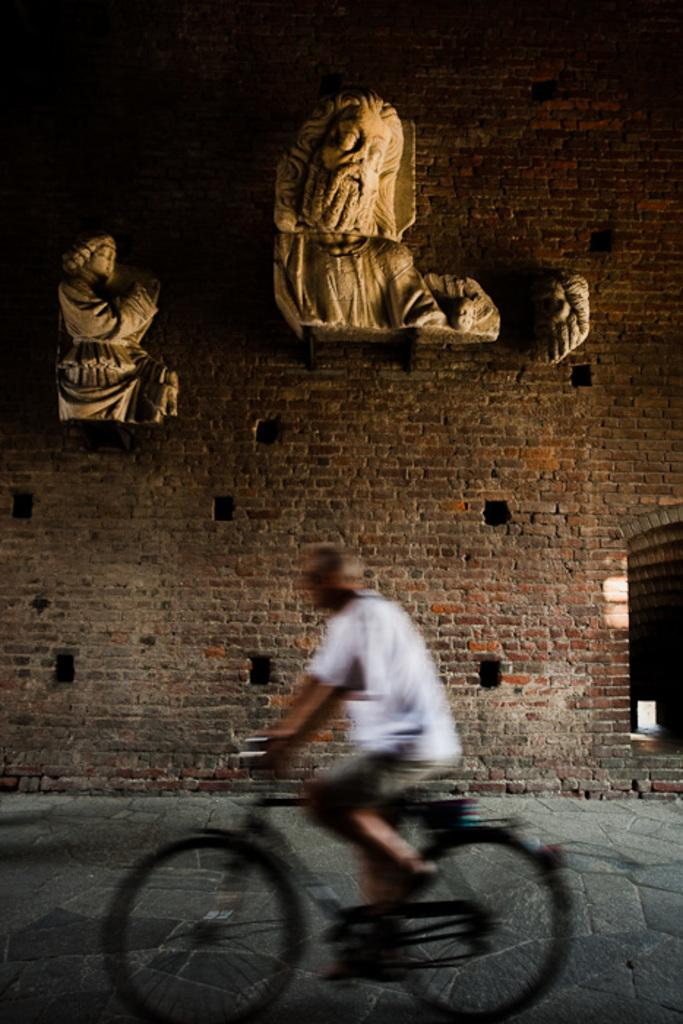What is the main subject of the image? There is a person in the image. What is the person wearing? The person is wearing a white t-shirt. What is the person doing in the image? The person is riding a black bicycle. What can be seen in the background of the image? There is a brick wall in the background, and there are two sculptures on the brick wall. Are there any noticeable features on the brick wall? Yes, there are holes in the brick wall. Can you tell me where the nest is located in the image? There is no nest present in the image. What type of bomb is being used in the competition in the image? There is no competition or bomb present in the image. 